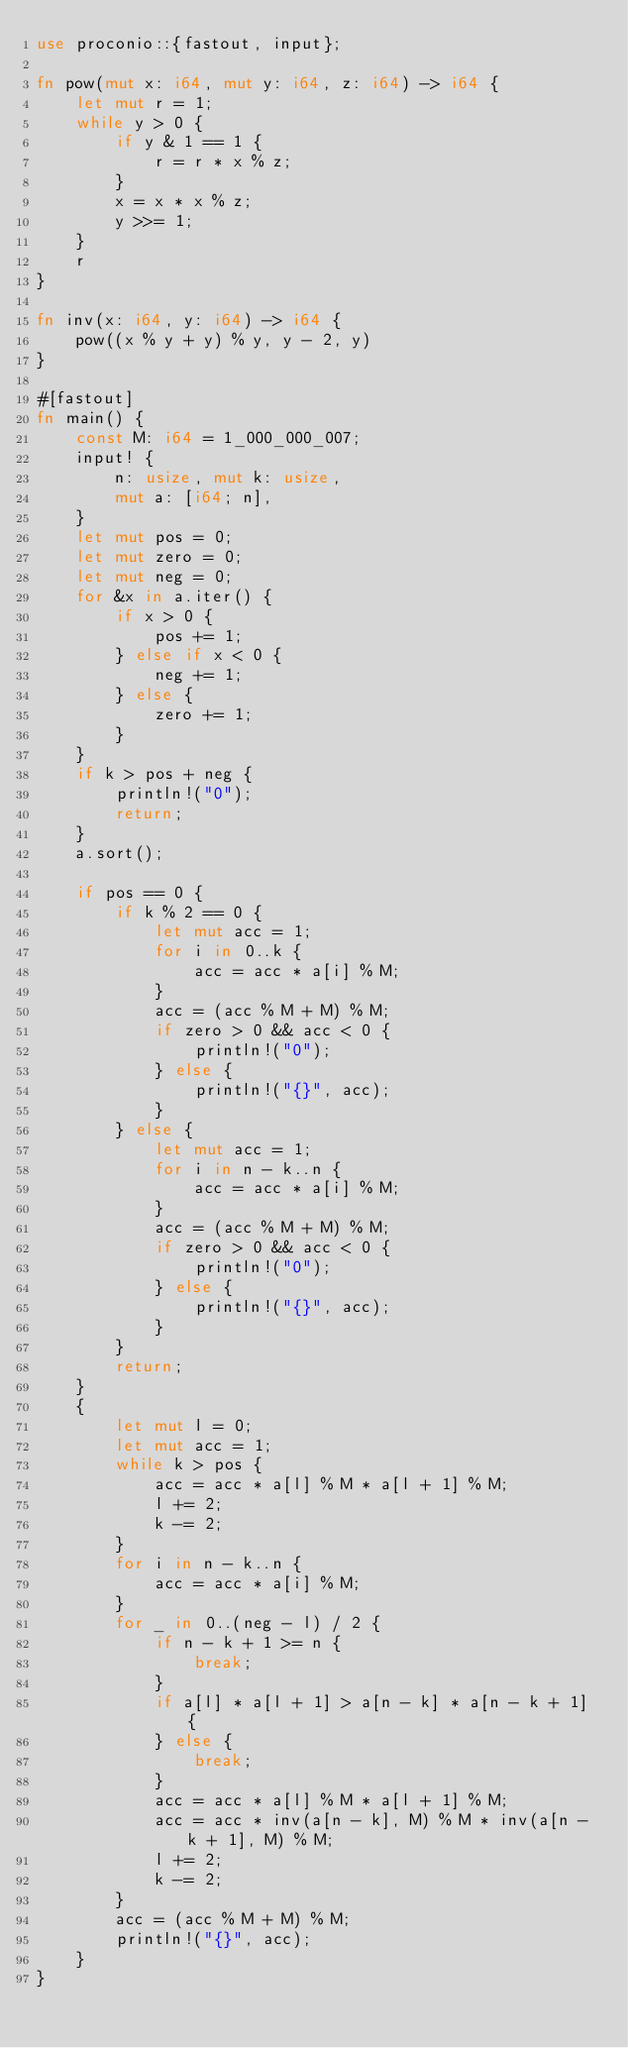Convert code to text. <code><loc_0><loc_0><loc_500><loc_500><_Rust_>use proconio::{fastout, input};

fn pow(mut x: i64, mut y: i64, z: i64) -> i64 {
    let mut r = 1;
    while y > 0 {
        if y & 1 == 1 {
            r = r * x % z;
        }
        x = x * x % z;
        y >>= 1;
    }
    r
}

fn inv(x: i64, y: i64) -> i64 {
    pow((x % y + y) % y, y - 2, y)
}

#[fastout]
fn main() {
    const M: i64 = 1_000_000_007;
    input! {
        n: usize, mut k: usize,
        mut a: [i64; n],
    }
    let mut pos = 0;
    let mut zero = 0;
    let mut neg = 0;
    for &x in a.iter() {
        if x > 0 {
            pos += 1;
        } else if x < 0 {
            neg += 1;
        } else {
            zero += 1;
        }
    }
    if k > pos + neg {
        println!("0");
        return;
    }
    a.sort();

    if pos == 0 {
        if k % 2 == 0 {
            let mut acc = 1;
            for i in 0..k {
                acc = acc * a[i] % M;
            }
            acc = (acc % M + M) % M;
            if zero > 0 && acc < 0 {
                println!("0");
            } else {
                println!("{}", acc);
            }
        } else {
            let mut acc = 1;
            for i in n - k..n {
                acc = acc * a[i] % M;
            }
            acc = (acc % M + M) % M;
            if zero > 0 && acc < 0 {
                println!("0");
            } else {
                println!("{}", acc);
            }
        }
        return;
    }
    {
        let mut l = 0;
        let mut acc = 1;
        while k > pos {
            acc = acc * a[l] % M * a[l + 1] % M;
            l += 2;
            k -= 2;
        }
        for i in n - k..n {
            acc = acc * a[i] % M;
        }
        for _ in 0..(neg - l) / 2 {
            if n - k + 1 >= n {
                break;
            }
            if a[l] * a[l + 1] > a[n - k] * a[n - k + 1] {
            } else {
                break;
            }
            acc = acc * a[l] % M * a[l + 1] % M;
            acc = acc * inv(a[n - k], M) % M * inv(a[n - k + 1], M) % M;
            l += 2;
            k -= 2;
        }
        acc = (acc % M + M) % M;
        println!("{}", acc);
    }
}
</code> 